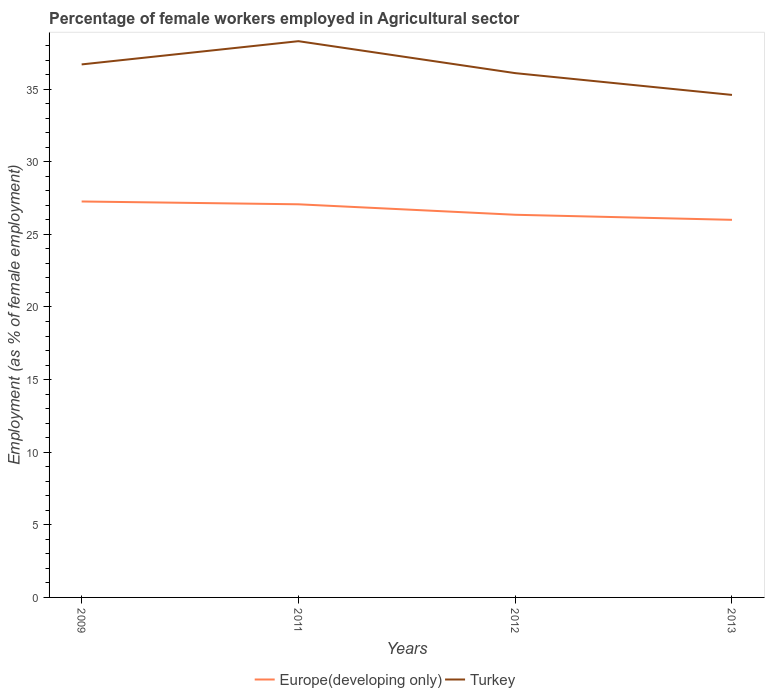How many different coloured lines are there?
Provide a short and direct response. 2. Across all years, what is the maximum percentage of females employed in Agricultural sector in Europe(developing only)?
Give a very brief answer. 26. What is the total percentage of females employed in Agricultural sector in Turkey in the graph?
Give a very brief answer. 3.7. What is the difference between the highest and the second highest percentage of females employed in Agricultural sector in Turkey?
Your response must be concise. 3.7. What is the difference between the highest and the lowest percentage of females employed in Agricultural sector in Europe(developing only)?
Offer a terse response. 2. How many lines are there?
Make the answer very short. 2. What is the difference between two consecutive major ticks on the Y-axis?
Your answer should be very brief. 5. How many legend labels are there?
Make the answer very short. 2. What is the title of the graph?
Provide a short and direct response. Percentage of female workers employed in Agricultural sector. What is the label or title of the Y-axis?
Provide a short and direct response. Employment (as % of female employment). What is the Employment (as % of female employment) in Europe(developing only) in 2009?
Ensure brevity in your answer.  27.26. What is the Employment (as % of female employment) of Turkey in 2009?
Make the answer very short. 36.7. What is the Employment (as % of female employment) of Europe(developing only) in 2011?
Your answer should be very brief. 27.07. What is the Employment (as % of female employment) in Turkey in 2011?
Give a very brief answer. 38.3. What is the Employment (as % of female employment) of Europe(developing only) in 2012?
Provide a short and direct response. 26.35. What is the Employment (as % of female employment) of Turkey in 2012?
Your response must be concise. 36.1. What is the Employment (as % of female employment) in Europe(developing only) in 2013?
Your answer should be very brief. 26. What is the Employment (as % of female employment) in Turkey in 2013?
Offer a very short reply. 34.6. Across all years, what is the maximum Employment (as % of female employment) of Europe(developing only)?
Give a very brief answer. 27.26. Across all years, what is the maximum Employment (as % of female employment) in Turkey?
Keep it short and to the point. 38.3. Across all years, what is the minimum Employment (as % of female employment) in Europe(developing only)?
Your answer should be very brief. 26. Across all years, what is the minimum Employment (as % of female employment) in Turkey?
Offer a very short reply. 34.6. What is the total Employment (as % of female employment) in Europe(developing only) in the graph?
Your answer should be very brief. 106.68. What is the total Employment (as % of female employment) in Turkey in the graph?
Keep it short and to the point. 145.7. What is the difference between the Employment (as % of female employment) of Europe(developing only) in 2009 and that in 2011?
Provide a short and direct response. 0.19. What is the difference between the Employment (as % of female employment) in Turkey in 2009 and that in 2011?
Make the answer very short. -1.6. What is the difference between the Employment (as % of female employment) of Europe(developing only) in 2009 and that in 2012?
Keep it short and to the point. 0.91. What is the difference between the Employment (as % of female employment) of Turkey in 2009 and that in 2012?
Provide a succinct answer. 0.6. What is the difference between the Employment (as % of female employment) in Europe(developing only) in 2009 and that in 2013?
Keep it short and to the point. 1.26. What is the difference between the Employment (as % of female employment) of Turkey in 2009 and that in 2013?
Provide a succinct answer. 2.1. What is the difference between the Employment (as % of female employment) in Europe(developing only) in 2011 and that in 2012?
Keep it short and to the point. 0.72. What is the difference between the Employment (as % of female employment) in Europe(developing only) in 2011 and that in 2013?
Offer a very short reply. 1.07. What is the difference between the Employment (as % of female employment) in Turkey in 2011 and that in 2013?
Keep it short and to the point. 3.7. What is the difference between the Employment (as % of female employment) in Europe(developing only) in 2012 and that in 2013?
Offer a very short reply. 0.35. What is the difference between the Employment (as % of female employment) of Turkey in 2012 and that in 2013?
Provide a succinct answer. 1.5. What is the difference between the Employment (as % of female employment) in Europe(developing only) in 2009 and the Employment (as % of female employment) in Turkey in 2011?
Offer a very short reply. -11.04. What is the difference between the Employment (as % of female employment) in Europe(developing only) in 2009 and the Employment (as % of female employment) in Turkey in 2012?
Your response must be concise. -8.84. What is the difference between the Employment (as % of female employment) in Europe(developing only) in 2009 and the Employment (as % of female employment) in Turkey in 2013?
Keep it short and to the point. -7.34. What is the difference between the Employment (as % of female employment) in Europe(developing only) in 2011 and the Employment (as % of female employment) in Turkey in 2012?
Offer a terse response. -9.03. What is the difference between the Employment (as % of female employment) of Europe(developing only) in 2011 and the Employment (as % of female employment) of Turkey in 2013?
Give a very brief answer. -7.53. What is the difference between the Employment (as % of female employment) in Europe(developing only) in 2012 and the Employment (as % of female employment) in Turkey in 2013?
Provide a short and direct response. -8.25. What is the average Employment (as % of female employment) in Europe(developing only) per year?
Offer a very short reply. 26.67. What is the average Employment (as % of female employment) in Turkey per year?
Provide a succinct answer. 36.42. In the year 2009, what is the difference between the Employment (as % of female employment) in Europe(developing only) and Employment (as % of female employment) in Turkey?
Ensure brevity in your answer.  -9.44. In the year 2011, what is the difference between the Employment (as % of female employment) of Europe(developing only) and Employment (as % of female employment) of Turkey?
Your answer should be compact. -11.23. In the year 2012, what is the difference between the Employment (as % of female employment) of Europe(developing only) and Employment (as % of female employment) of Turkey?
Offer a very short reply. -9.75. In the year 2013, what is the difference between the Employment (as % of female employment) of Europe(developing only) and Employment (as % of female employment) of Turkey?
Offer a very short reply. -8.6. What is the ratio of the Employment (as % of female employment) of Europe(developing only) in 2009 to that in 2011?
Your answer should be very brief. 1.01. What is the ratio of the Employment (as % of female employment) in Turkey in 2009 to that in 2011?
Make the answer very short. 0.96. What is the ratio of the Employment (as % of female employment) of Europe(developing only) in 2009 to that in 2012?
Ensure brevity in your answer.  1.03. What is the ratio of the Employment (as % of female employment) of Turkey in 2009 to that in 2012?
Give a very brief answer. 1.02. What is the ratio of the Employment (as % of female employment) in Europe(developing only) in 2009 to that in 2013?
Offer a terse response. 1.05. What is the ratio of the Employment (as % of female employment) of Turkey in 2009 to that in 2013?
Provide a succinct answer. 1.06. What is the ratio of the Employment (as % of female employment) in Europe(developing only) in 2011 to that in 2012?
Your response must be concise. 1.03. What is the ratio of the Employment (as % of female employment) of Turkey in 2011 to that in 2012?
Your response must be concise. 1.06. What is the ratio of the Employment (as % of female employment) in Europe(developing only) in 2011 to that in 2013?
Offer a terse response. 1.04. What is the ratio of the Employment (as % of female employment) of Turkey in 2011 to that in 2013?
Make the answer very short. 1.11. What is the ratio of the Employment (as % of female employment) of Europe(developing only) in 2012 to that in 2013?
Offer a terse response. 1.01. What is the ratio of the Employment (as % of female employment) of Turkey in 2012 to that in 2013?
Your answer should be very brief. 1.04. What is the difference between the highest and the second highest Employment (as % of female employment) in Europe(developing only)?
Offer a very short reply. 0.19. What is the difference between the highest and the lowest Employment (as % of female employment) in Europe(developing only)?
Ensure brevity in your answer.  1.26. What is the difference between the highest and the lowest Employment (as % of female employment) of Turkey?
Ensure brevity in your answer.  3.7. 